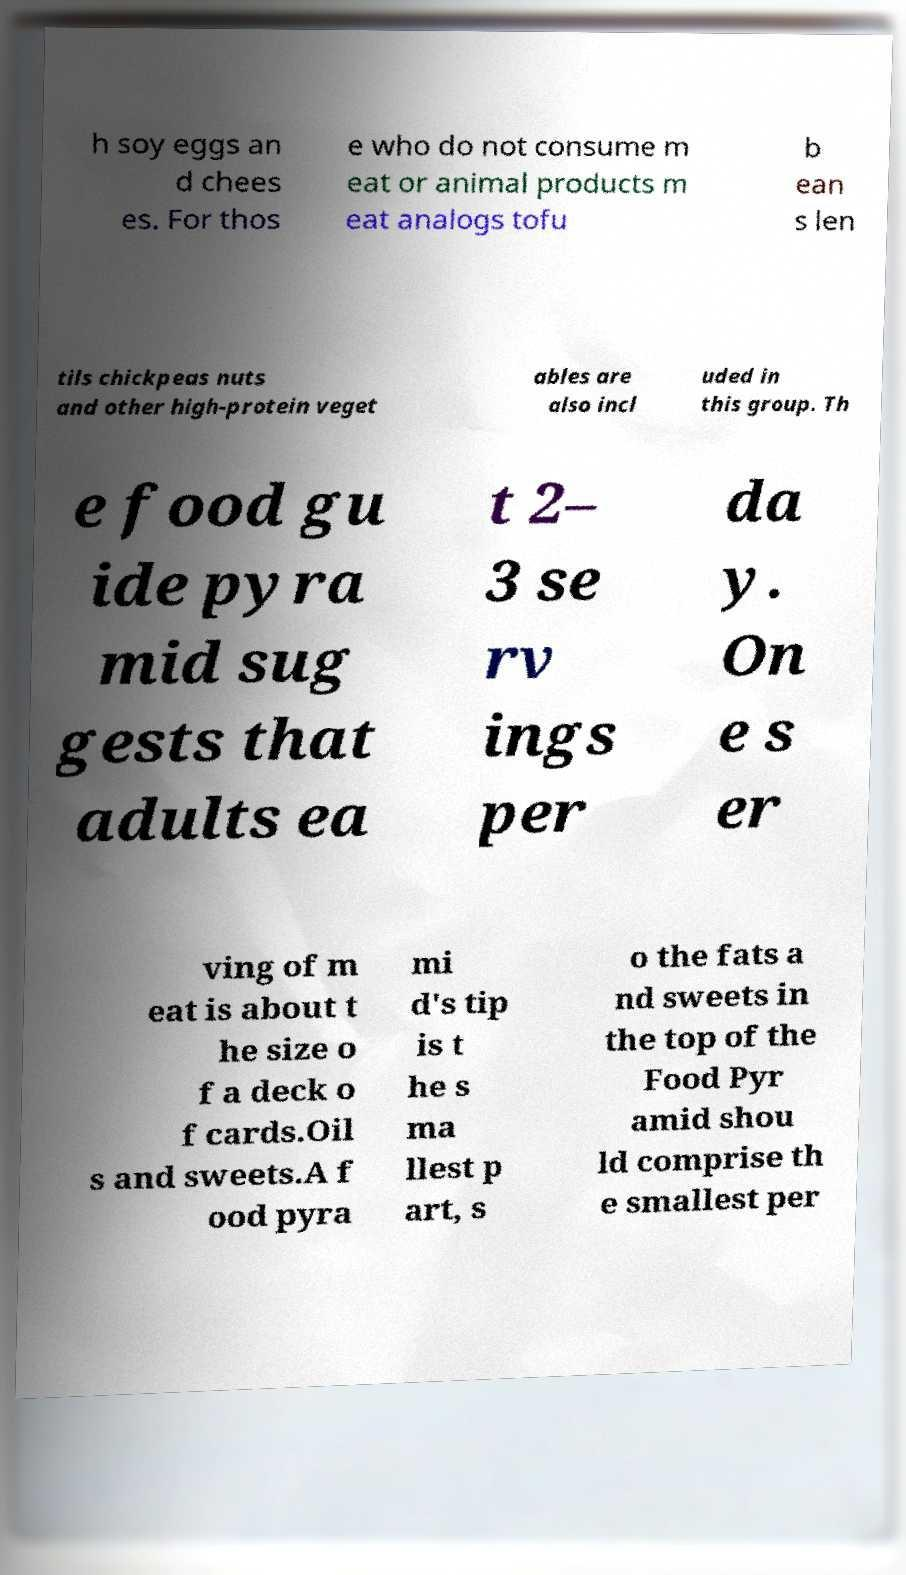There's text embedded in this image that I need extracted. Can you transcribe it verbatim? h soy eggs an d chees es. For thos e who do not consume m eat or animal products m eat analogs tofu b ean s len tils chickpeas nuts and other high-protein veget ables are also incl uded in this group. Th e food gu ide pyra mid sug gests that adults ea t 2– 3 se rv ings per da y. On e s er ving of m eat is about t he size o f a deck o f cards.Oil s and sweets.A f ood pyra mi d's tip is t he s ma llest p art, s o the fats a nd sweets in the top of the Food Pyr amid shou ld comprise th e smallest per 